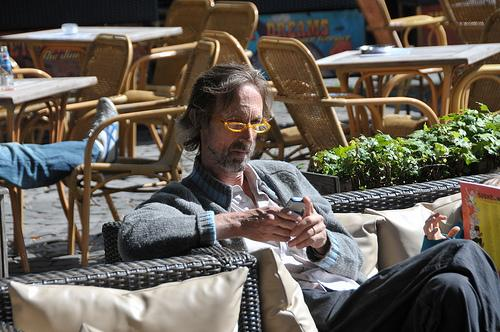What is the man wearing? glasses 